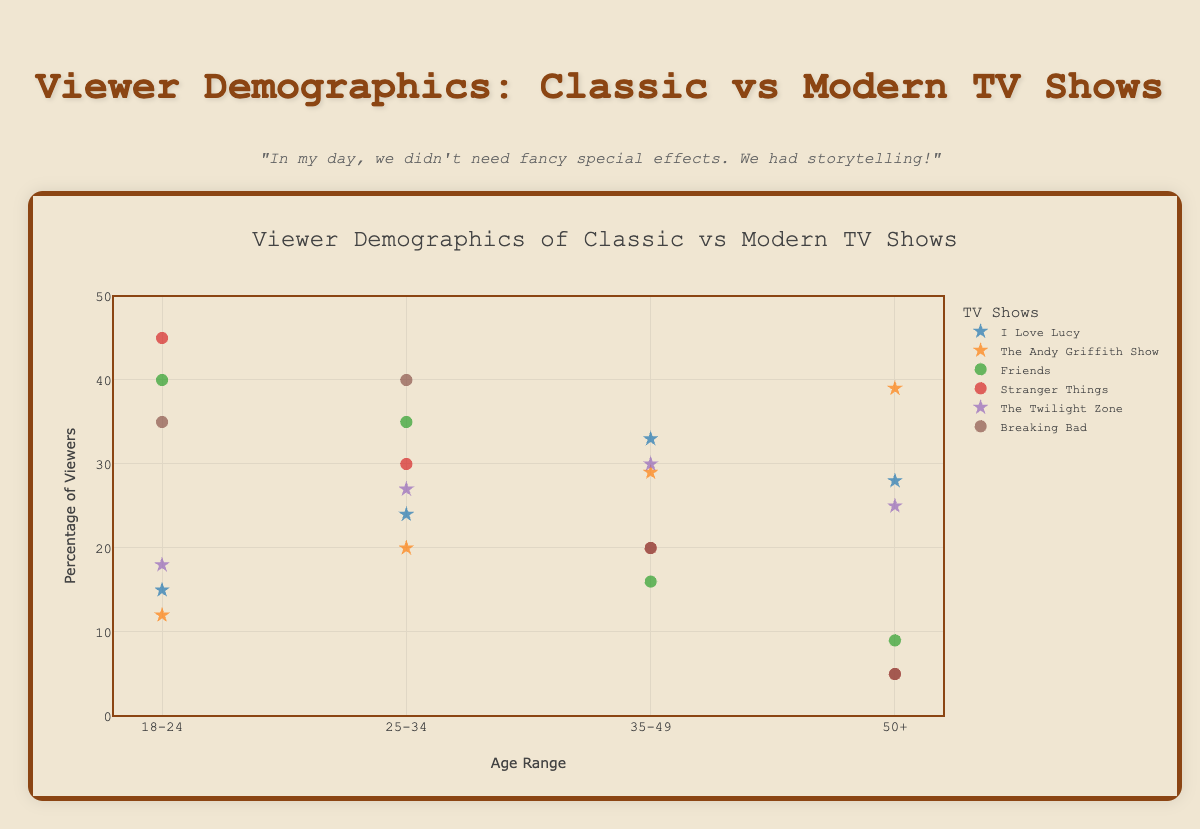How many age ranges are presented on the x-axis? By looking at the x-axis of the chart, we can count the distinct age ranges labeled such as "18-24", "25-34", "35-49", and "50+".
Answer: 4 What is the title of the chart? The title of the chart is displayed at the top center. It provides an overview of the chart's content.
Answer: Viewer Demographics of Classic vs Modern TV Shows Which age range has the highest percentage of viewers for "Stranger Things"? To determine this, locate the age ranges on the x-axis and find the corresponding data points for "Stranger Things" colored scatter points.
Answer: 18-24 What is the difference in the viewer percentage between the oldest age range (50+) and the youngest age range (18-24) for "Friends"? Locate the "Friends" scatter points for the age ranges 50+ and 18-24 and subtract the percentage for 50+ from the percentage for 18-24.
Answer: 31 Which show has the highest viewer percentage for the age range "35-49"? Identify the data points on the chart for the age range "35-49" across all shows and find the maximum value.
Answer: I Love Lucy What is the combined percentage of viewers aged 25-34 for "I Love Lucy" and "Breaking Bad"? Find the percentage values for the age range "25-34" for both "I Love Lucy" and "Breaking Bad" and sum them up.
Answer: 64% How does the viewer percentage for the age range "18-24" compare between classic and modern shows? Compare the data points for all classic and modern shows in the age range "18-24" to identify the trend.
Answer: Modern TV shows have higher percentages What percentage of viewers aged 50+ watch "The Andy Griffith Show"? Look for the data point on the chart for "The Andy Griffith Show" in the "50+" age range.
Answer: 39% Which era has higher viewer percentages in the age range "25-34", classic or modern? Compare the scatter points for the age range "25-34" between all classic and modern TV shows to determine the higher percentages.
Answer: Modern Which TV show has the most balanced viewer percentages across all age ranges? Assess the scatter points for each TV show to identify the one with relatively even percentages across all age ranges.
Answer: The Twilight Zone 